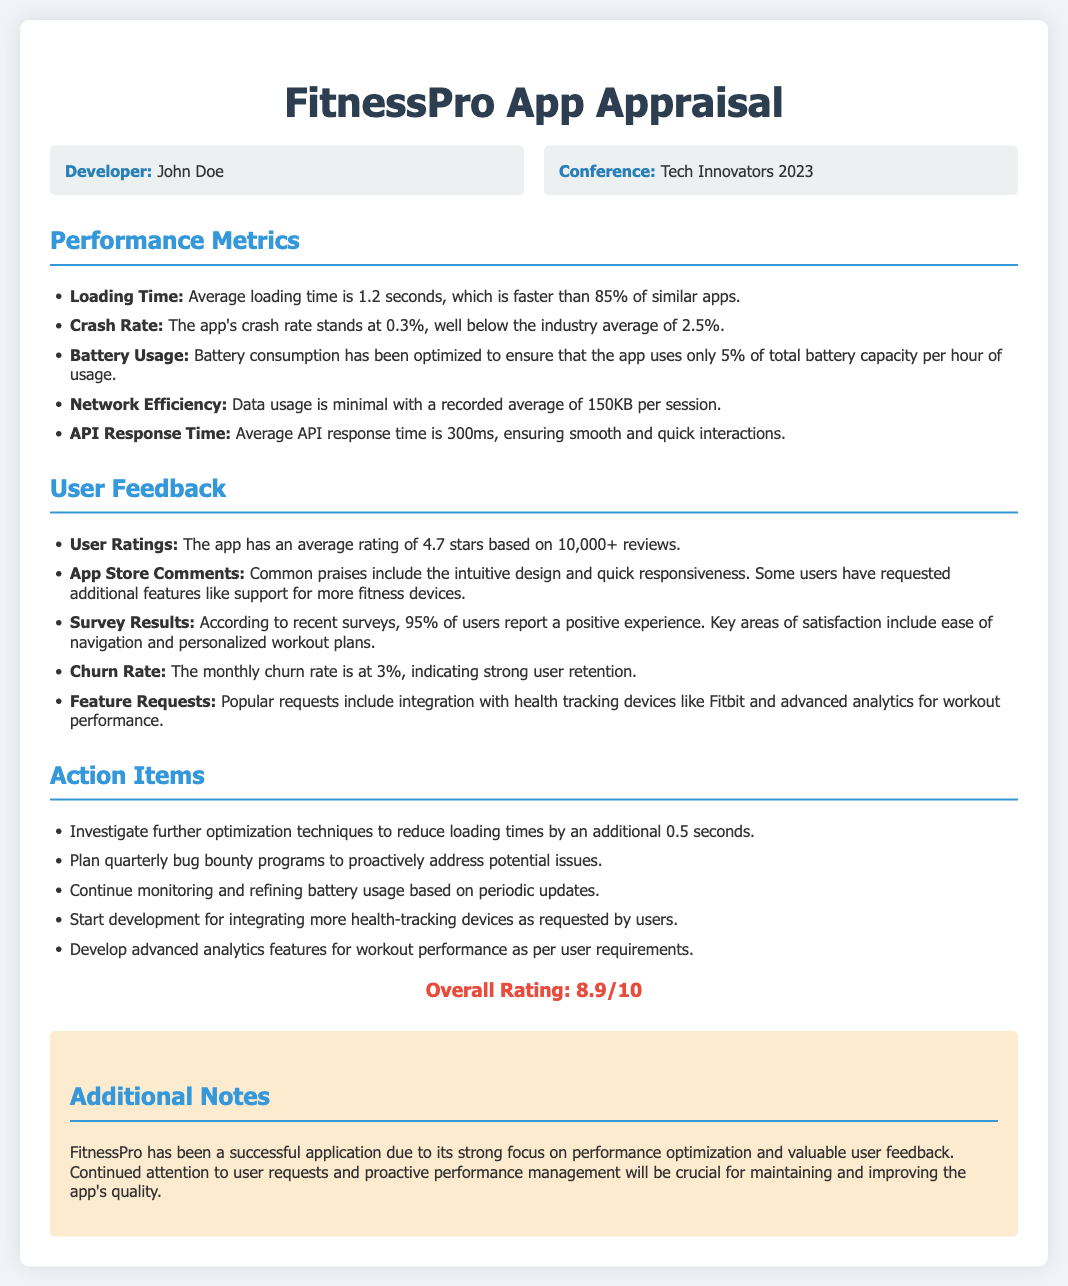What is the average loading time? The average loading time is specified under Performance Metrics, which indicates it is 1.2 seconds.
Answer: 1.2 seconds What is the crash rate of the app? The crash rate is mentioned in the Performance Metrics section and is noted as 0.3%.
Answer: 0.3% What is the average rating of the app? User Ratings under User Feedback indicates the app has an average rating of 4.7 stars.
Answer: 4.7 stars What percentage of users report a positive experience? The Survey Results section states that 95% of users report a positive experience.
Answer: 95% What is the monthly churn rate? The churn rate is explicitly mentioned in the User Feedback and is at 3%.
Answer: 3% How many reviews were considered for the average rating? The document mentions that the average rating is based on 10,000+ reviews.
Answer: 10,000+ reviews What are popular feature requests? Popular requests are listed under User Feedback, including integration with health tracking devices and advanced analytics.
Answer: Integration with health tracking devices, advanced analytics Who is the developer of the app? The developer's name is provided in the info-grid at the beginning of the document.
Answer: John Doe What is the overall rating of the app? The overall rating is provided at the end of the document and is noted as 8.9 out of 10.
Answer: 8.9/10 